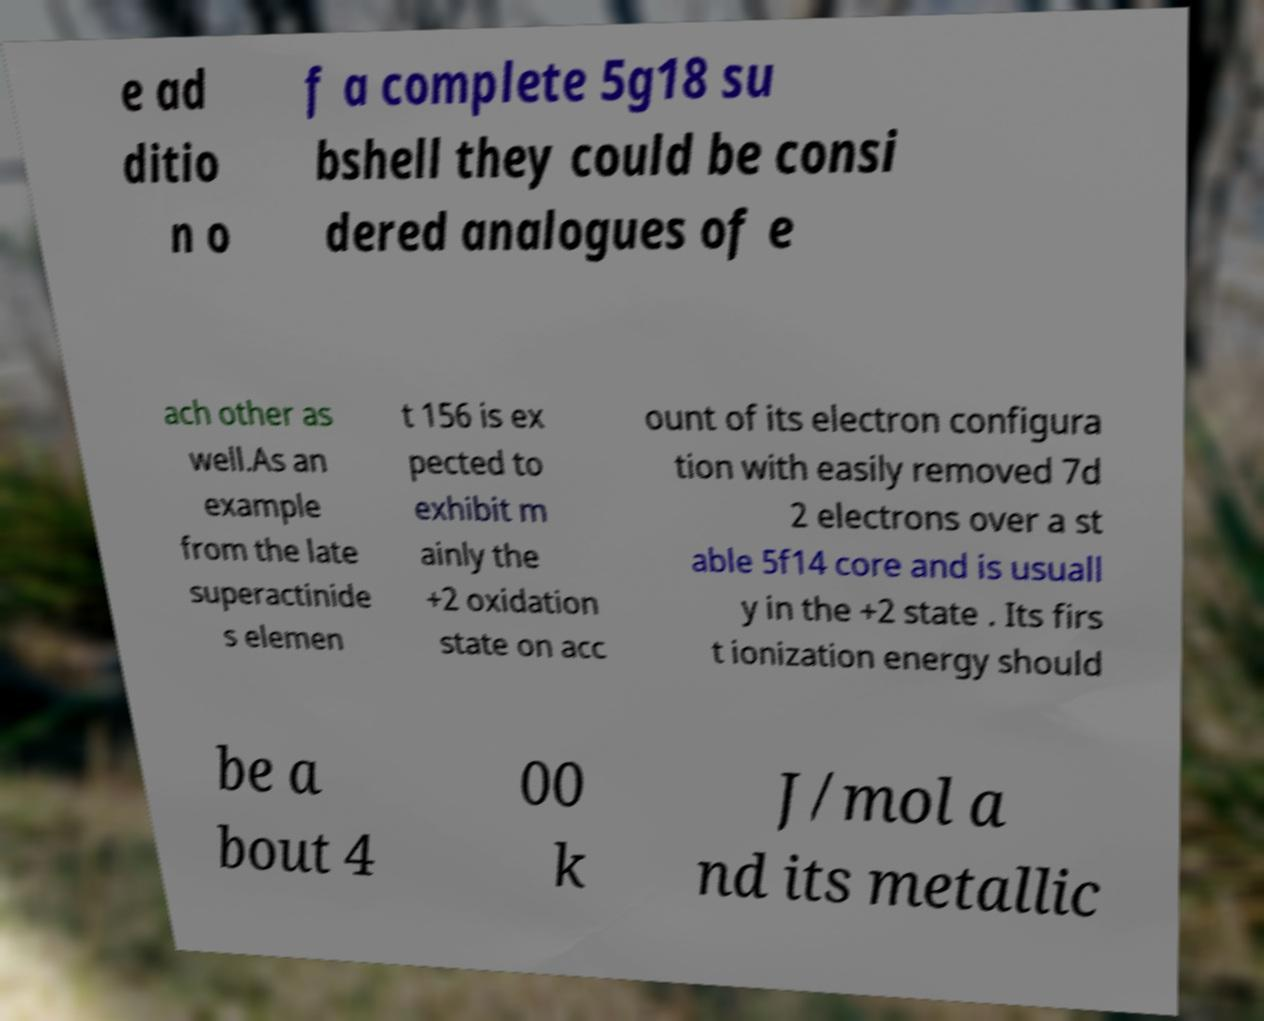Could you assist in decoding the text presented in this image and type it out clearly? e ad ditio n o f a complete 5g18 su bshell they could be consi dered analogues of e ach other as well.As an example from the late superactinide s elemen t 156 is ex pected to exhibit m ainly the +2 oxidation state on acc ount of its electron configura tion with easily removed 7d 2 electrons over a st able 5f14 core and is usuall y in the +2 state . Its firs t ionization energy should be a bout 4 00 k J/mol a nd its metallic 